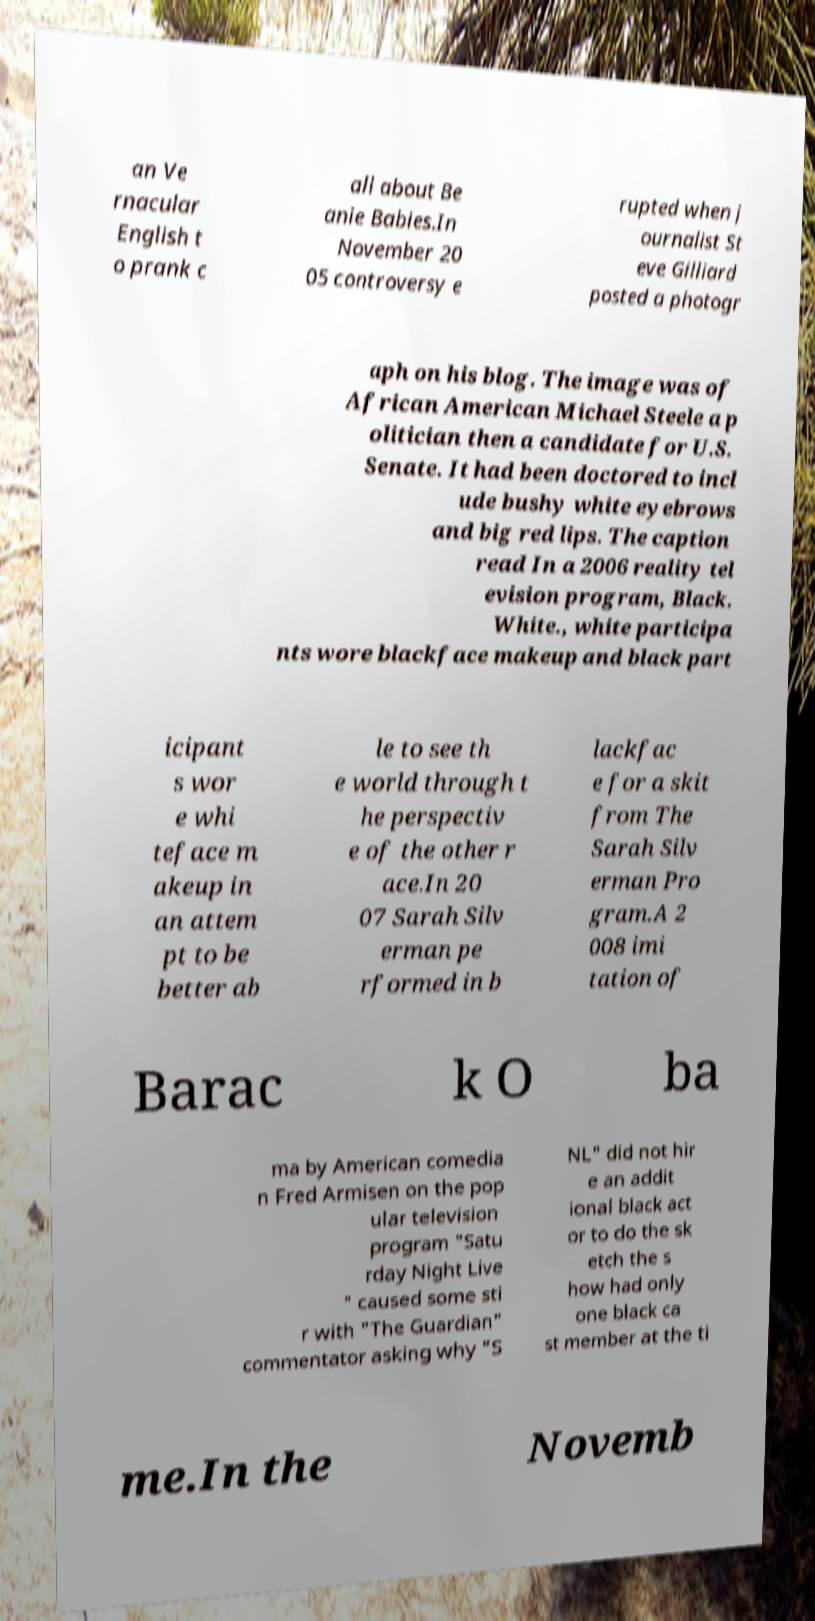Could you assist in decoding the text presented in this image and type it out clearly? an Ve rnacular English t o prank c all about Be anie Babies.In November 20 05 controversy e rupted when j ournalist St eve Gilliard posted a photogr aph on his blog. The image was of African American Michael Steele a p olitician then a candidate for U.S. Senate. It had been doctored to incl ude bushy white eyebrows and big red lips. The caption read In a 2006 reality tel evision program, Black. White., white participa nts wore blackface makeup and black part icipant s wor e whi teface m akeup in an attem pt to be better ab le to see th e world through t he perspectiv e of the other r ace.In 20 07 Sarah Silv erman pe rformed in b lackfac e for a skit from The Sarah Silv erman Pro gram.A 2 008 imi tation of Barac k O ba ma by American comedia n Fred Armisen on the pop ular television program "Satu rday Night Live " caused some sti r with "The Guardian" commentator asking why "S NL" did not hir e an addit ional black act or to do the sk etch the s how had only one black ca st member at the ti me.In the Novemb 